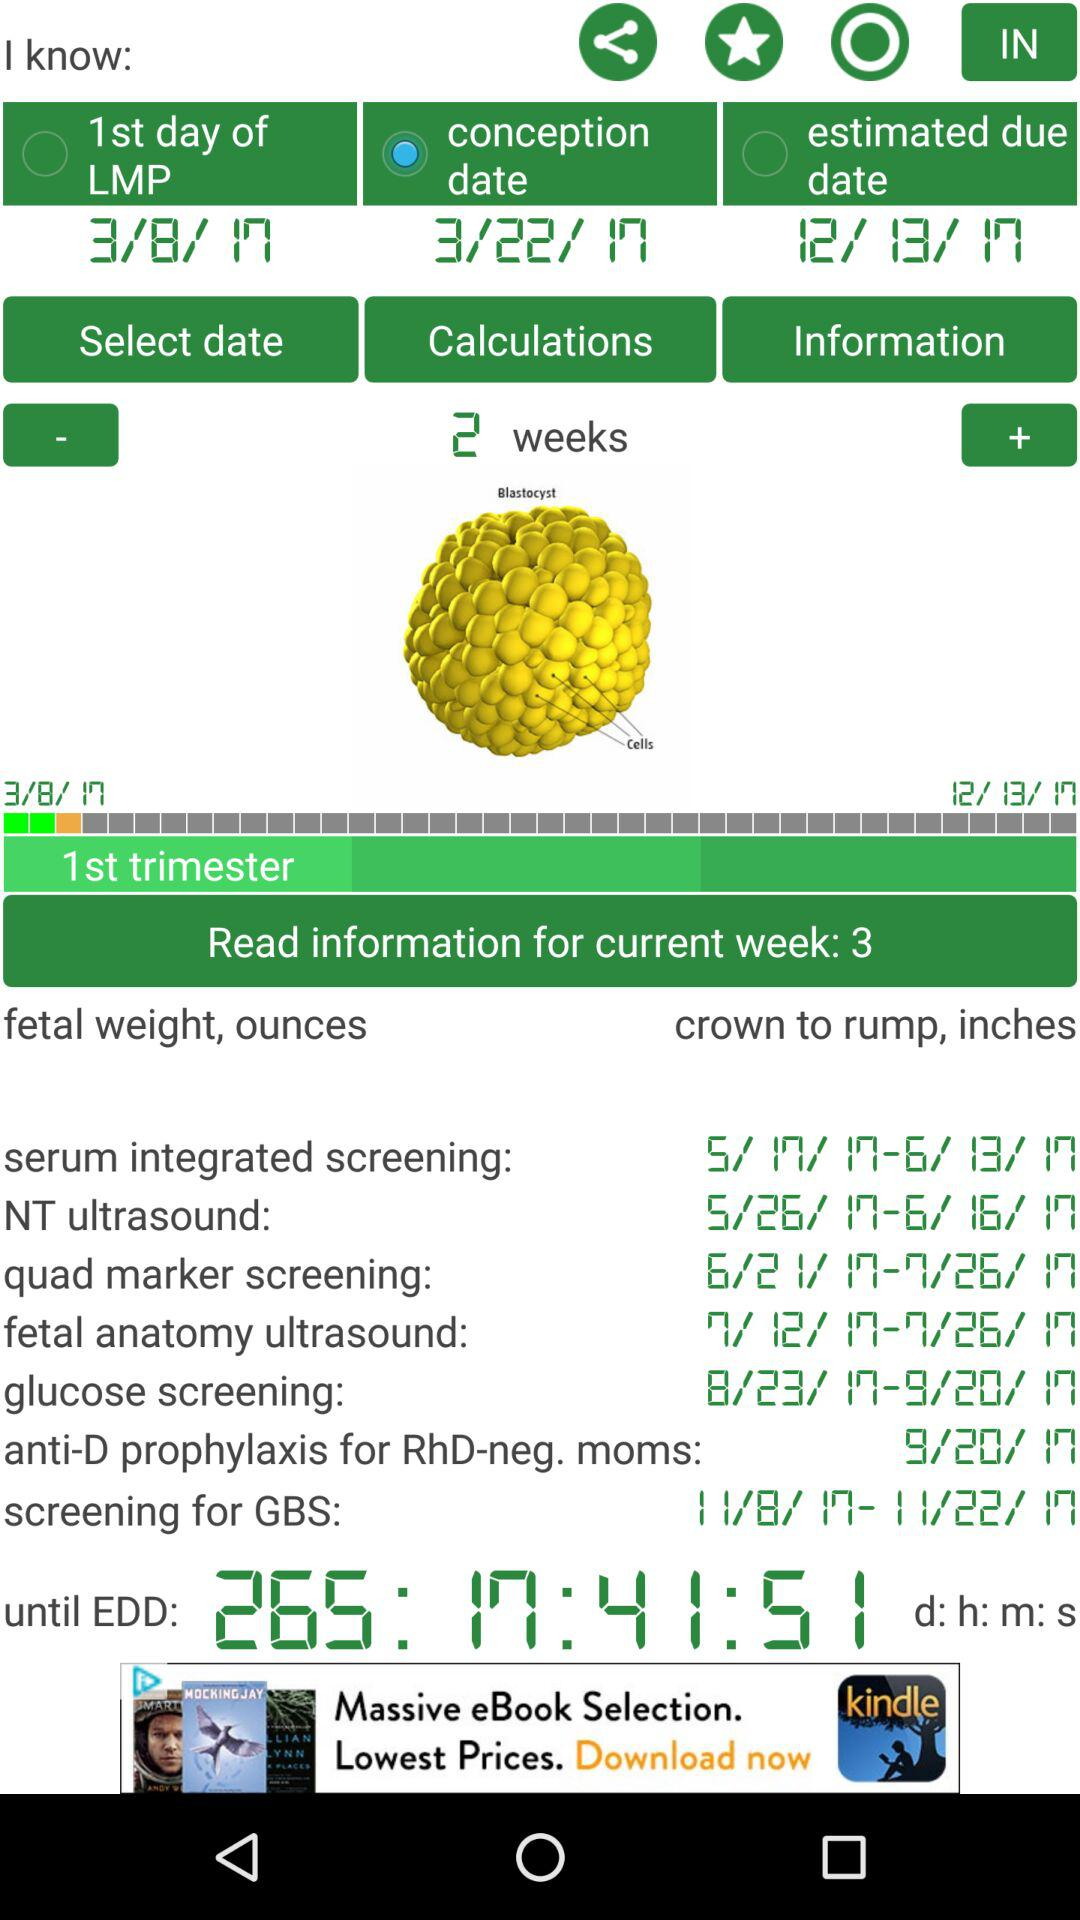What is the estimated due date? The estimated due date is December 13, 2017. 